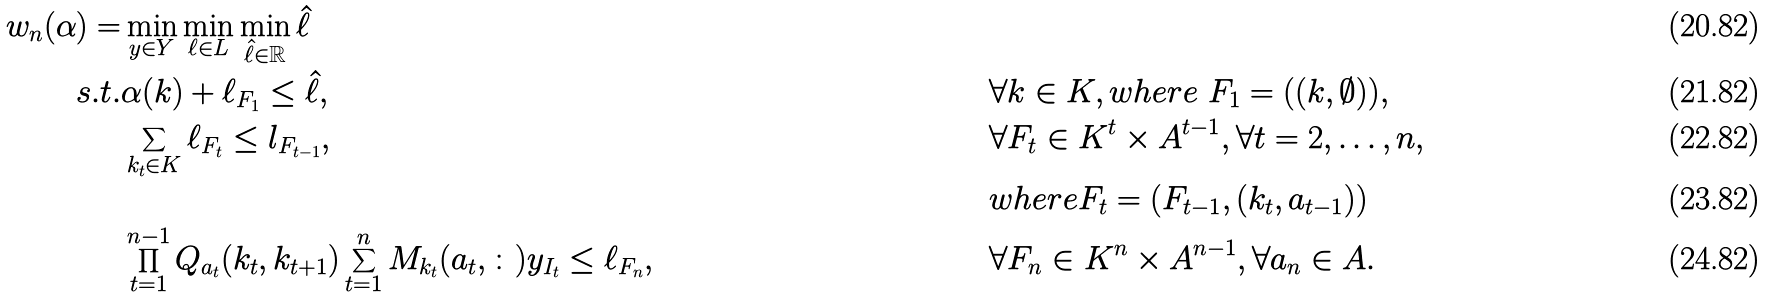<formula> <loc_0><loc_0><loc_500><loc_500>w _ { n } ( \alpha ) = & \min _ { y \in Y } \min _ { \ell \in L } \min _ { \hat { \ell } \in \mathbb { R } } \hat { \ell } \\ s . t . & \alpha ( k ) + \ell _ { F _ { 1 } } \leq \hat { \ell } , & & \forall k \in K , w h e r e \ F _ { 1 } = ( ( k , \emptyset ) ) , \\ & \sum _ { k _ { t } \in K } \ell _ { F _ { t } } \leq l _ { F _ { t - 1 } } , & & \forall F _ { t } \in K ^ { t } \times A ^ { t - 1 } , \forall t = 2 , \dots , n , \\ & & & w h e r e F _ { t } = ( F _ { t - 1 } , ( k _ { t } , a _ { t - 1 } ) ) \\ & \prod _ { t = 1 } ^ { n - 1 } Q _ { a _ { t } } ( k _ { t } , k _ { t + 1 } ) \sum _ { t = 1 } ^ { n } M _ { k _ { t } } ( a _ { t } , \colon ) y _ { I _ { t } } \leq \ell _ { F _ { n } } , & & \forall F _ { n } \in K ^ { n } \times A ^ { n - 1 } , \forall a _ { n } \in A .</formula> 